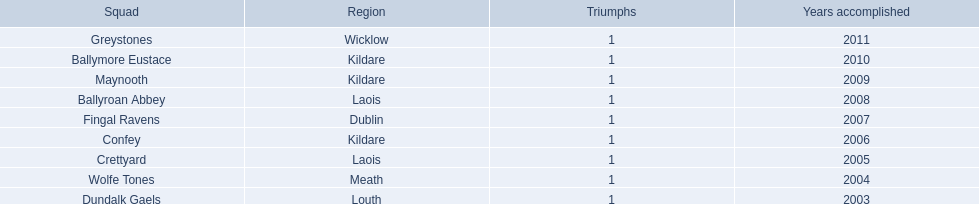What county is the team that won in 2009 from? Kildare. What is the teams name? Maynooth. 